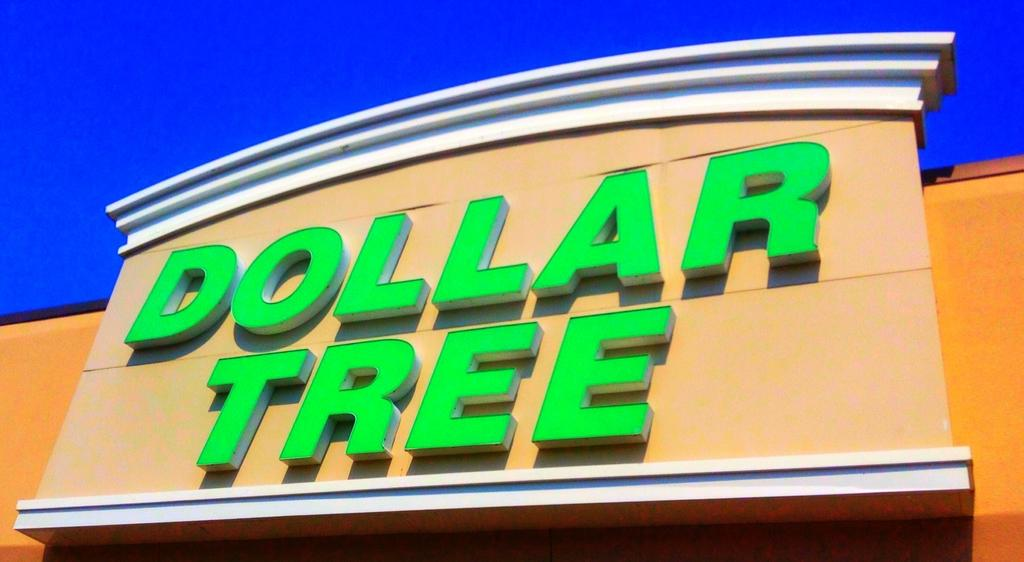What type of structure is visible in the image? There is a building in the image. What is written on the building? The building has "dollar tree" written on it. What type of metal is the police officer's badge made of in the image? There is no police officer or badge present in the image. Can you describe the color of the ray that is flying over the building in the image? There is no ray present in the image. 